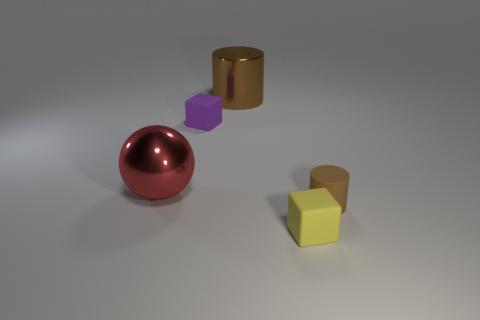Add 5 purple things. How many objects exist? 10 Subtract all balls. How many objects are left? 4 Add 1 big red metal spheres. How many big red metal spheres are left? 2 Add 4 cubes. How many cubes exist? 6 Subtract 0 yellow spheres. How many objects are left? 5 Subtract all small green matte objects. Subtract all tiny brown cylinders. How many objects are left? 4 